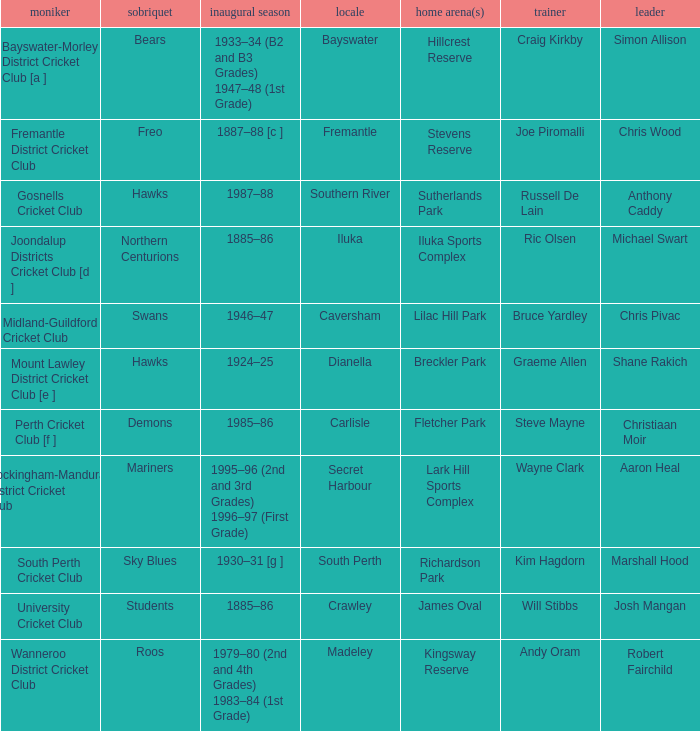On which dates is hillcrest reserve utilized as the home grounds? 1933–34 (B2 and B3 Grades) 1947–48 (1st Grade). Give me the full table as a dictionary. {'header': ['moniker', 'sobriquet', 'inaugural season', 'locale', 'home arena(s)', 'trainer', 'leader'], 'rows': [['Bayswater-Morley District Cricket Club [a ]', 'Bears', '1933–34 (B2 and B3 Grades) 1947–48 (1st Grade)', 'Bayswater', 'Hillcrest Reserve', 'Craig Kirkby', 'Simon Allison'], ['Fremantle District Cricket Club', 'Freo', '1887–88 [c ]', 'Fremantle', 'Stevens Reserve', 'Joe Piromalli', 'Chris Wood'], ['Gosnells Cricket Club', 'Hawks', '1987–88', 'Southern River', 'Sutherlands Park', 'Russell De Lain', 'Anthony Caddy'], ['Joondalup Districts Cricket Club [d ]', 'Northern Centurions', '1885–86', 'Iluka', 'Iluka Sports Complex', 'Ric Olsen', 'Michael Swart'], ['Midland-Guildford Cricket Club', 'Swans', '1946–47', 'Caversham', 'Lilac Hill Park', 'Bruce Yardley', 'Chris Pivac'], ['Mount Lawley District Cricket Club [e ]', 'Hawks', '1924–25', 'Dianella', 'Breckler Park', 'Graeme Allen', 'Shane Rakich'], ['Perth Cricket Club [f ]', 'Demons', '1985–86', 'Carlisle', 'Fletcher Park', 'Steve Mayne', 'Christiaan Moir'], ['Rockingham-Mandurah District Cricket Club', 'Mariners', '1995–96 (2nd and 3rd Grades) 1996–97 (First Grade)', 'Secret Harbour', 'Lark Hill Sports Complex', 'Wayne Clark', 'Aaron Heal'], ['South Perth Cricket Club', 'Sky Blues', '1930–31 [g ]', 'South Perth', 'Richardson Park', 'Kim Hagdorn', 'Marshall Hood'], ['University Cricket Club', 'Students', '1885–86', 'Crawley', 'James Oval', 'Will Stibbs', 'Josh Mangan'], ['Wanneroo District Cricket Club', 'Roos', '1979–80 (2nd and 4th Grades) 1983–84 (1st Grade)', 'Madeley', 'Kingsway Reserve', 'Andy Oram', 'Robert Fairchild']]} 